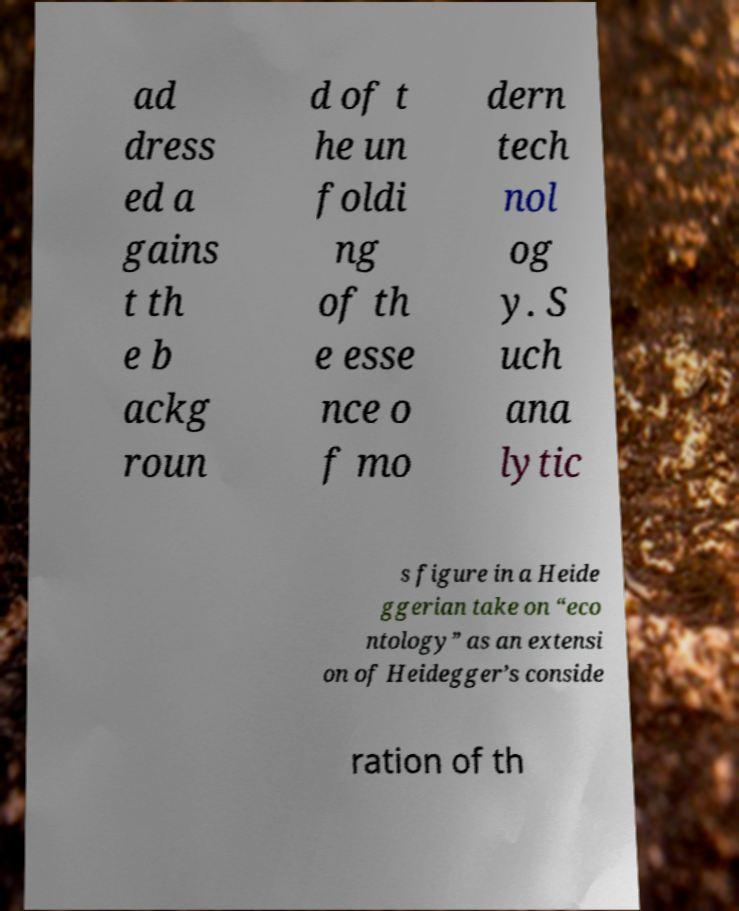What messages or text are displayed in this image? I need them in a readable, typed format. ad dress ed a gains t th e b ackg roun d of t he un foldi ng of th e esse nce o f mo dern tech nol og y. S uch ana lytic s figure in a Heide ggerian take on “eco ntology” as an extensi on of Heidegger’s conside ration of th 